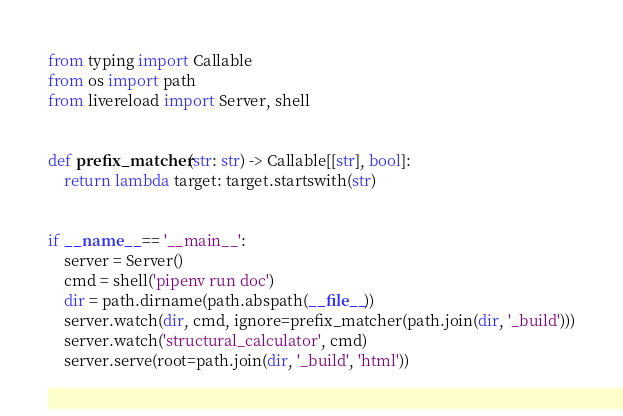<code> <loc_0><loc_0><loc_500><loc_500><_Python_>from typing import Callable
from os import path
from livereload import Server, shell


def prefix_matcher(str: str) -> Callable[[str], bool]:
    return lambda target: target.startswith(str)


if __name__ == '__main__':
    server = Server()
    cmd = shell('pipenv run doc')
    dir = path.dirname(path.abspath(__file__))
    server.watch(dir, cmd, ignore=prefix_matcher(path.join(dir, '_build')))
    server.watch('structural_calculator', cmd)
    server.serve(root=path.join(dir, '_build', 'html'))
</code> 